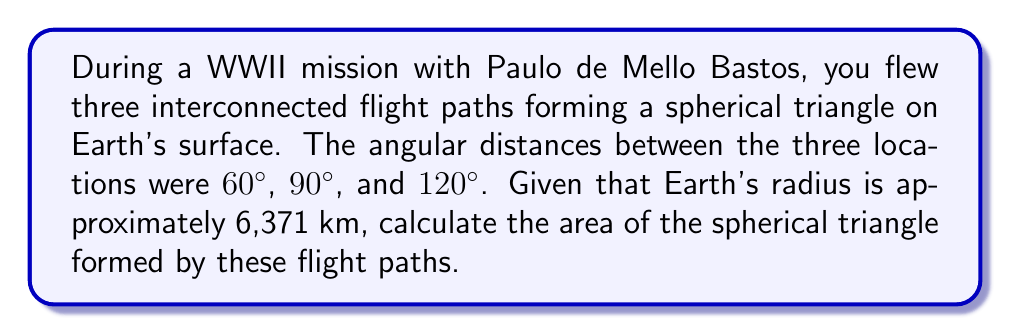Could you help me with this problem? To solve this problem, we'll use the formula for the area of a spherical triangle, known as Girard's Theorem:

$$A = R^2 (a + b + c - \pi)$$

Where:
- $A$ is the area of the spherical triangle
- $R$ is the radius of the sphere (Earth in this case)
- $a$, $b$, and $c$ are the angles of the spherical triangle in radians

Step 1: Convert the given angles from degrees to radians:
$$60° = \frac{\pi}{3} \text{ rad}$$
$$90° = \frac{\pi}{2} \text{ rad}$$
$$120° = \frac{2\pi}{3} \text{ rad}$$

Step 2: Apply Girard's Theorem:
$$A = R^2 \left(\frac{\pi}{3} + \frac{\pi}{2} + \frac{2\pi}{3} - \pi\right)$$

Step 3: Simplify the expression inside the parentheses:
$$A = R^2 \left(\frac{\pi}{3} + \frac{\pi}{2} + \frac{2\pi}{3} - \pi\right) = R^2 \left(\frac{3\pi}{6} + \frac{6\pi}{12} + \frac{8\pi}{12} - \frac{12\pi}{12}\right) = R^2 \left(\frac{\pi}{2}\right)$$

Step 4: Substitute the value of Earth's radius (6,371 km):
$$A = (6,371 \text{ km})^2 \cdot \frac{\pi}{2} \approx 63,783,573 \text{ km}^2$$

Therefore, the area of the spherical triangle formed by the flight paths is approximately 63,783,573 square kilometers.
Answer: 63,783,573 km² 